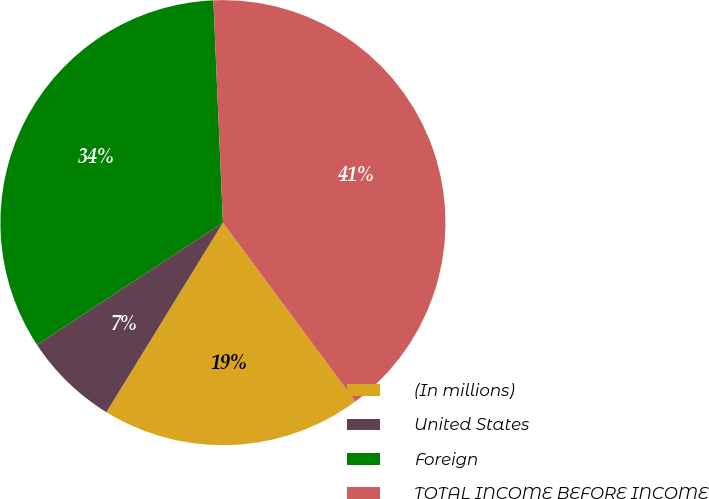<chart> <loc_0><loc_0><loc_500><loc_500><pie_chart><fcel>(In millions)<fcel>United States<fcel>Foreign<fcel>TOTAL INCOME BEFORE INCOME<nl><fcel>18.92%<fcel>6.97%<fcel>33.57%<fcel>40.54%<nl></chart> 